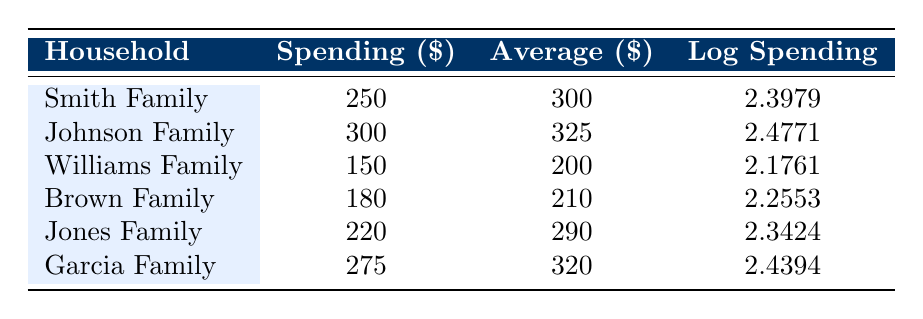What is the highest annual spending on educational supplies among the households listed? The table displays the spending for each household. The highest amount is 300 for the Johnson Family.
Answer: 300 Which household spends less than the average for similar households? The table shows the spending and averages for each household. The Williams Family spends 150, which is less than its average of 200. Similarly, the Brown Family spends 180, which is also less than its average of 210.
Answer: Williams Family, Brown Family What is the difference between the highest and lowest spending on educational supplies? The highest spending is 300 (Johnson Family) and the lowest is 150 (Williams Family). The difference is calculated as 300 - 150 = 150.
Answer: 150 Is the Garcia Family's spending higher than the average for similar households? The Garcia Family spends 275, and their average is 320. Since 275 is less than 320, the statement is false.
Answer: No What is the average spending on educational supplies across all households? To find the average, sum all the spending amounts: 250 + 300 + 150 + 180 + 220 + 275 = 1375. There are 6 households, so the average is 1375 / 6 ≈ 229.17.
Answer: 229.17 Which family has the highest log spending value, and what is that value? The log spending values are listed in the table. The highest is 2.4771 for the Johnson Family.
Answer: 2.4771 How much more does the Jones Family spend compared to the Williams Family on educational supplies? The Jones Family spends 220 while the Williams Family spends 150. The difference is 220 - 150 = 70.
Answer: 70 Is the average spending of the Johnson Family lower than the average of the Smith Family? The Johnson Family's average is 325, while the Smith Family's average is 300. Since 325 is greater than 300, this statement is false.
Answer: No 